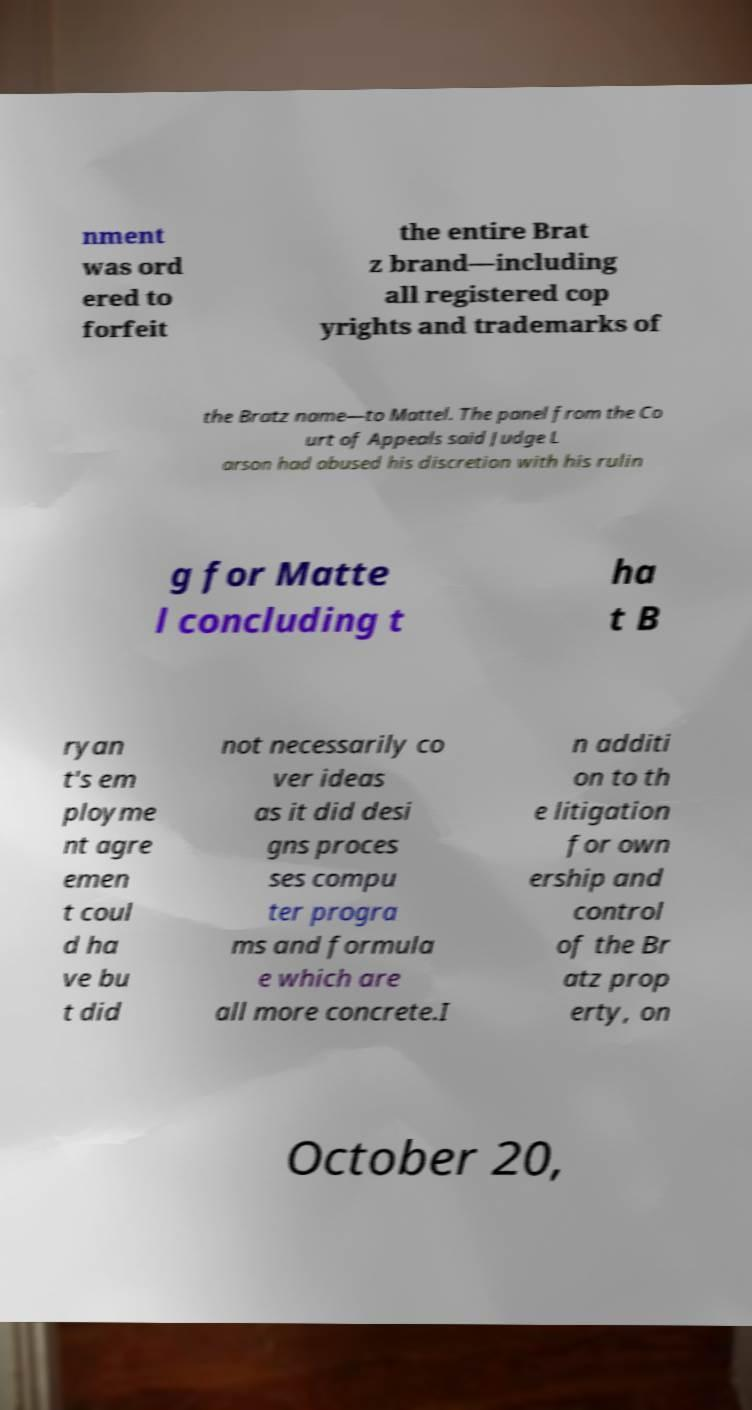What messages or text are displayed in this image? I need them in a readable, typed format. nment was ord ered to forfeit the entire Brat z brand—including all registered cop yrights and trademarks of the Bratz name—to Mattel. The panel from the Co urt of Appeals said Judge L arson had abused his discretion with his rulin g for Matte l concluding t ha t B ryan t's em ployme nt agre emen t coul d ha ve bu t did not necessarily co ver ideas as it did desi gns proces ses compu ter progra ms and formula e which are all more concrete.I n additi on to th e litigation for own ership and control of the Br atz prop erty, on October 20, 